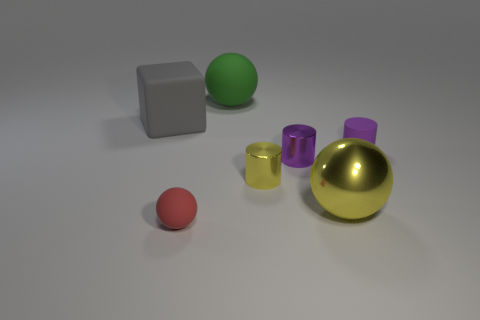Is there a tiny purple rubber object of the same shape as the purple metal thing?
Offer a terse response. Yes. What number of other blocks are made of the same material as the big cube?
Your response must be concise. 0. Is the large object that is on the left side of the small red sphere made of the same material as the small yellow object?
Your answer should be very brief. No. Is the number of small yellow cylinders that are on the right side of the big matte block greater than the number of gray things that are in front of the small red object?
Your response must be concise. Yes. There is a yellow object that is the same size as the cube; what material is it?
Ensure brevity in your answer.  Metal. What number of other objects are there of the same material as the tiny ball?
Make the answer very short. 3. There is a large object that is to the right of the green rubber thing; does it have the same shape as the big gray rubber thing that is behind the yellow shiny cylinder?
Your response must be concise. No. What number of other things are the same color as the shiny ball?
Your response must be concise. 1. Does the small purple object left of the large metal object have the same material as the big thing to the left of the red matte thing?
Your answer should be compact. No. Are there an equal number of small purple cylinders to the right of the tiny red rubber sphere and big yellow shiny balls behind the large gray thing?
Give a very brief answer. No. 